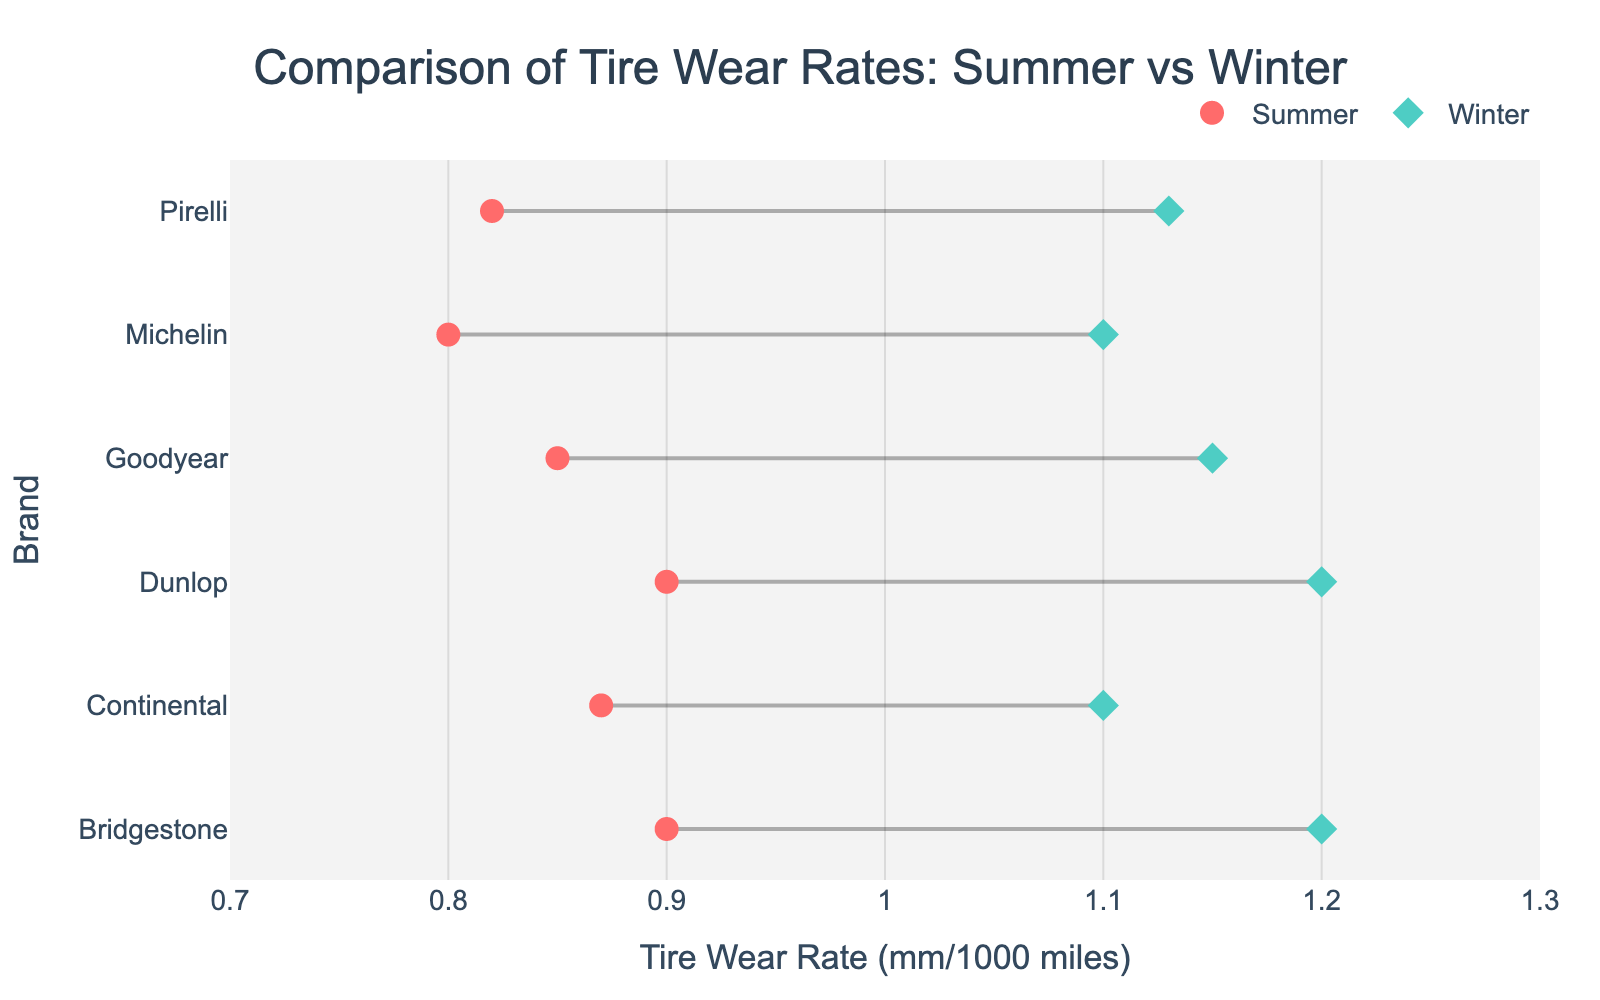what is the title of the plot? The title of the plot is displayed at the centered, top section of the figure; it typically summarizes the context or main content being depicted.
Answer: "Comparison of Tire Wear Rates: Summer vs Winter" how many brands are compared in the plot? To determine the number of brands compared, count the unique labels along the y-axis of the plot, which represents each brand involved in the comparison.
Answer: 6 what is the tire wear rate range displayed on the x-axis? The x-axis range can be seen by looking at the minimum and maximum values marked on the x-axis. In this case, it shows from 0.7 to 1.3 mm/1000 miles.
Answer: 0.7 to 1.3 mm/1000 miles which brand has the smallest difference between summer and winter tire wear rates? By examining the distance between the summer and winter tire wear rate markers for each brand, we can identify the brand with the smallest gap. Pirelli shows the least difference.
Answer: Pirelli what is the average tire wear rate for summer tires across all brands? To find the average, add up all the summer tire wear rates and divide by the number of brands: (0.8 + 0.9 + 0.85 + 0.87 + 0.82 + 0.9) / 6 = 5.14 / 6
Answer: 0.8567 mm/1000 miles which type of tire generally has a higher wear rate, summer or winter? By comparing the overall positions of the summer and winter markers across all brands, we observe that winter tires tend to have higher wear rates consistently.
Answer: Winter tires which brand has the highest tire wear rate for winter tires? By looking at the highest marker among all the winter tire wear rate markers, you will see that Bridgestone and Dunlop both have the highest rate of 1.2 mm/1000 miles.
Answer: Bridgestone and Dunlop what is the difference in tire wear rate for Goodyear between summer and winter tires? The difference can be calculated by subtracting Goodyear's summer tire wear rate from its winter tire wear rate: 1.15 - 0.85 = 0.3 mm/1000 miles.
Answer: 0.3 mm/1000 miles which brand's summer and winter wear rates are equal? All brands show some difference between the summer and winter wear rates; thus, no brand has equal wear rates for both tires in the dataset.
Answer: None which color represents the summer tires in the plot? By observing the legend in the figure, which associates color with marker types, the summer tire markers are represented by circles colored red.
Answer: Red 